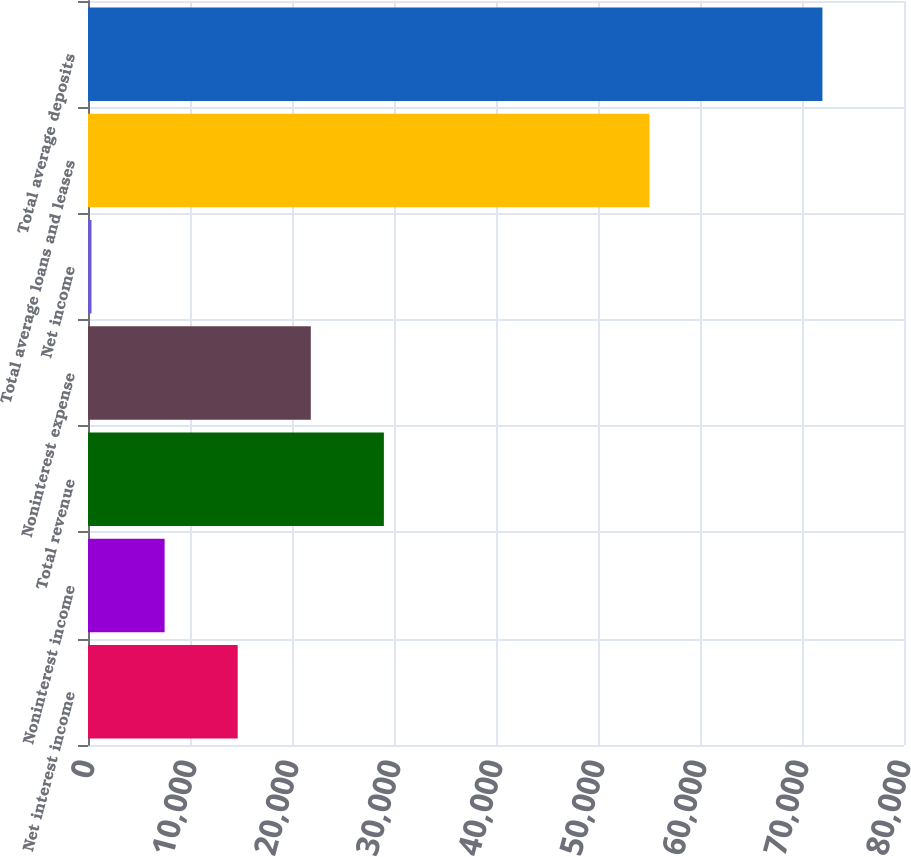Convert chart to OTSL. <chart><loc_0><loc_0><loc_500><loc_500><bar_chart><fcel>Net interest income<fcel>Noninterest income<fcel>Total revenue<fcel>Noninterest expense<fcel>Net income<fcel>Total average loans and leases<fcel>Total average deposits<nl><fcel>14676.6<fcel>7510.8<fcel>29008.2<fcel>21842.4<fcel>345<fcel>55052<fcel>72003<nl></chart> 